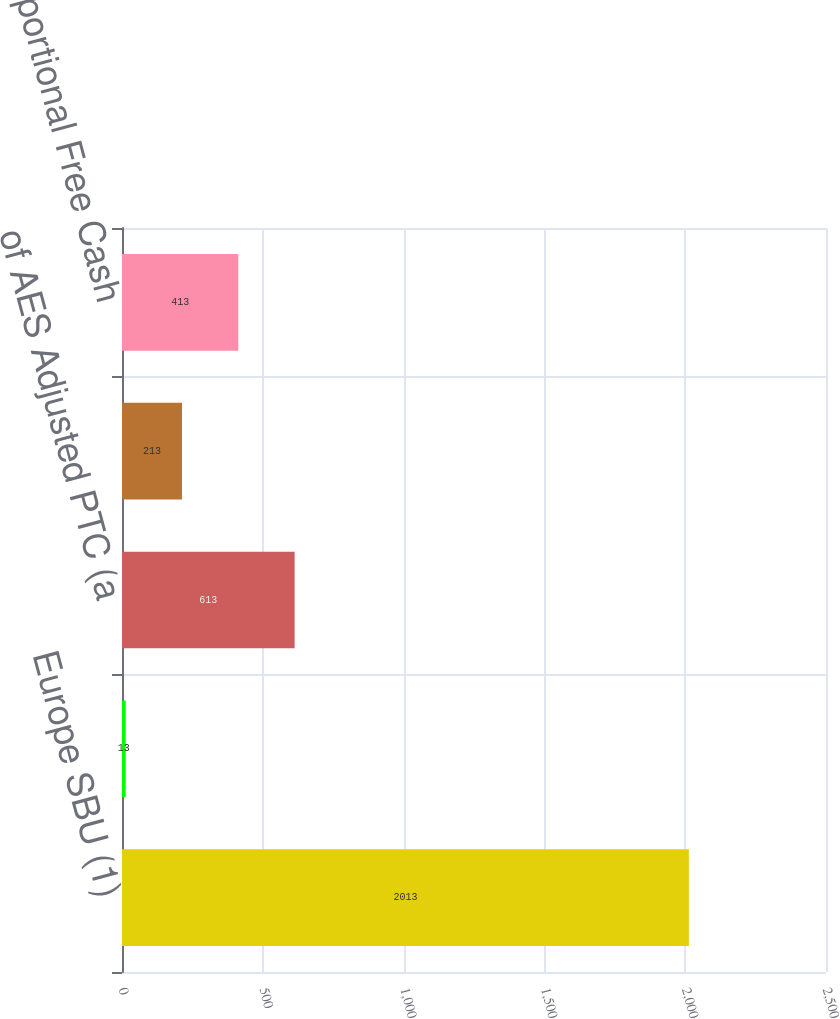Convert chart. <chart><loc_0><loc_0><loc_500><loc_500><bar_chart><fcel>Europe SBU (1)<fcel>of AES Operating Margin<fcel>of AES Adjusted PTC (a<fcel>of AES Operating Cash Flow<fcel>of AES Proportional Free Cash<nl><fcel>2013<fcel>13<fcel>613<fcel>213<fcel>413<nl></chart> 